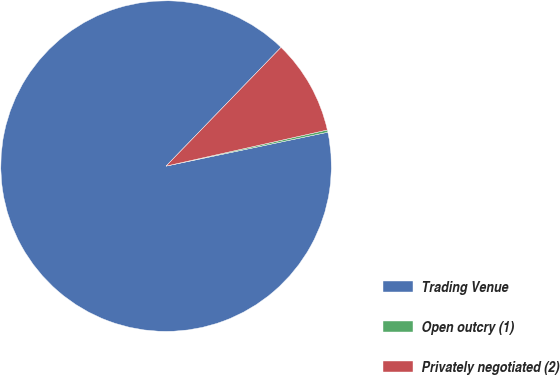<chart> <loc_0><loc_0><loc_500><loc_500><pie_chart><fcel>Trading Venue<fcel>Open outcry (1)<fcel>Privately negotiated (2)<nl><fcel>90.52%<fcel>0.22%<fcel>9.25%<nl></chart> 